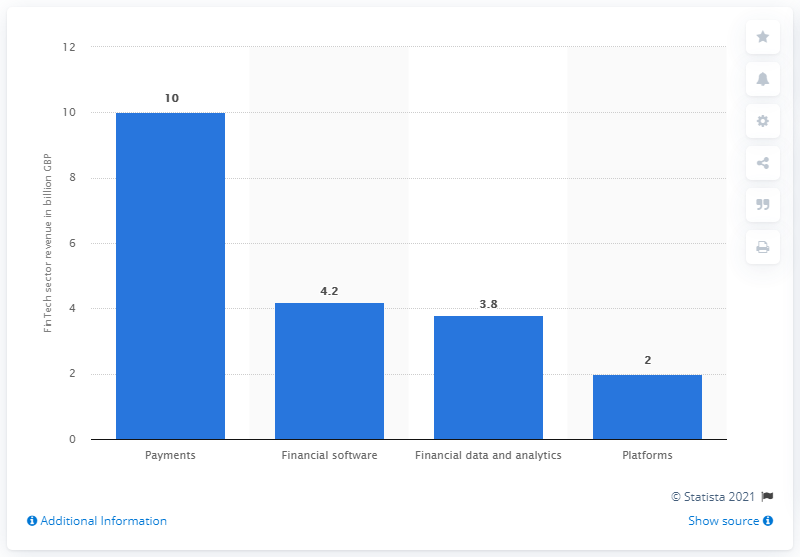Point out several critical features in this image. In August 2014, the subsector of payments generated a certain amount of revenue. 